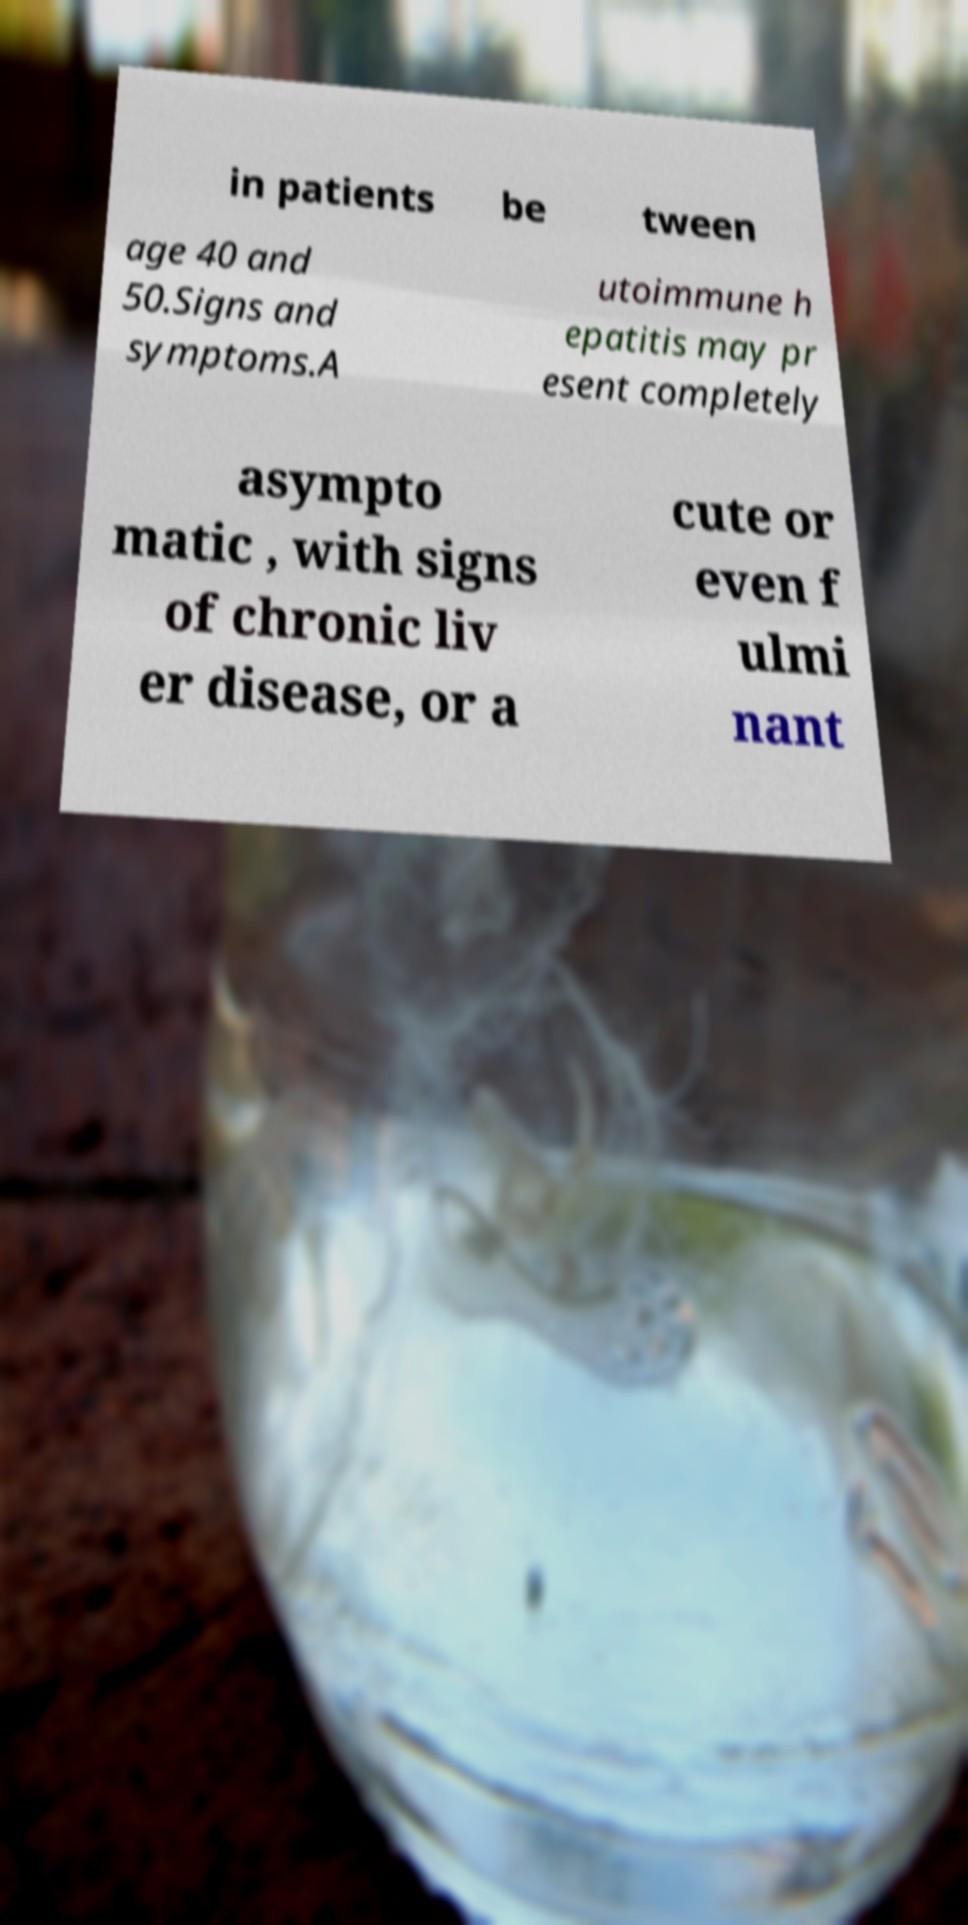Can you accurately transcribe the text from the provided image for me? in patients be tween age 40 and 50.Signs and symptoms.A utoimmune h epatitis may pr esent completely asympto matic , with signs of chronic liv er disease, or a cute or even f ulmi nant 